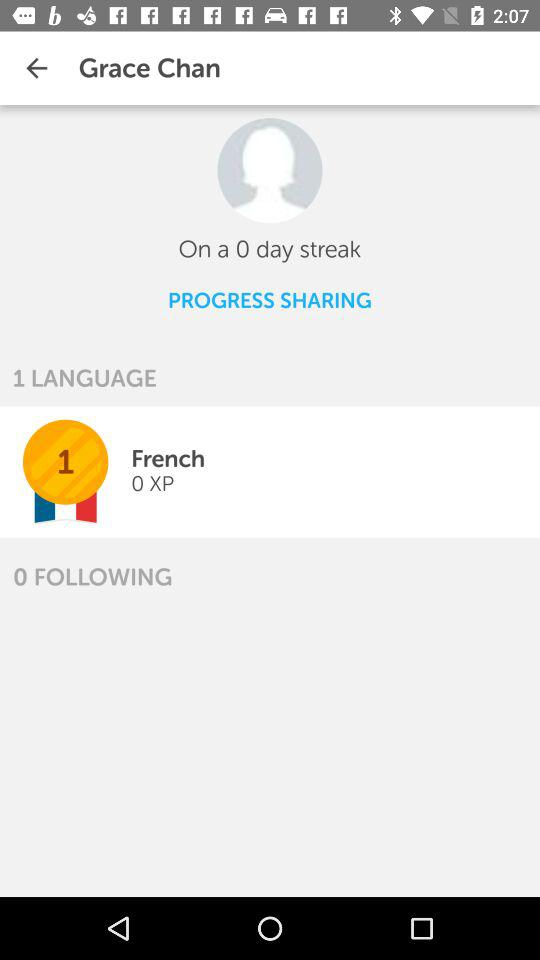How many XP does Grace Chan have?
Answer the question using a single word or phrase. 0 